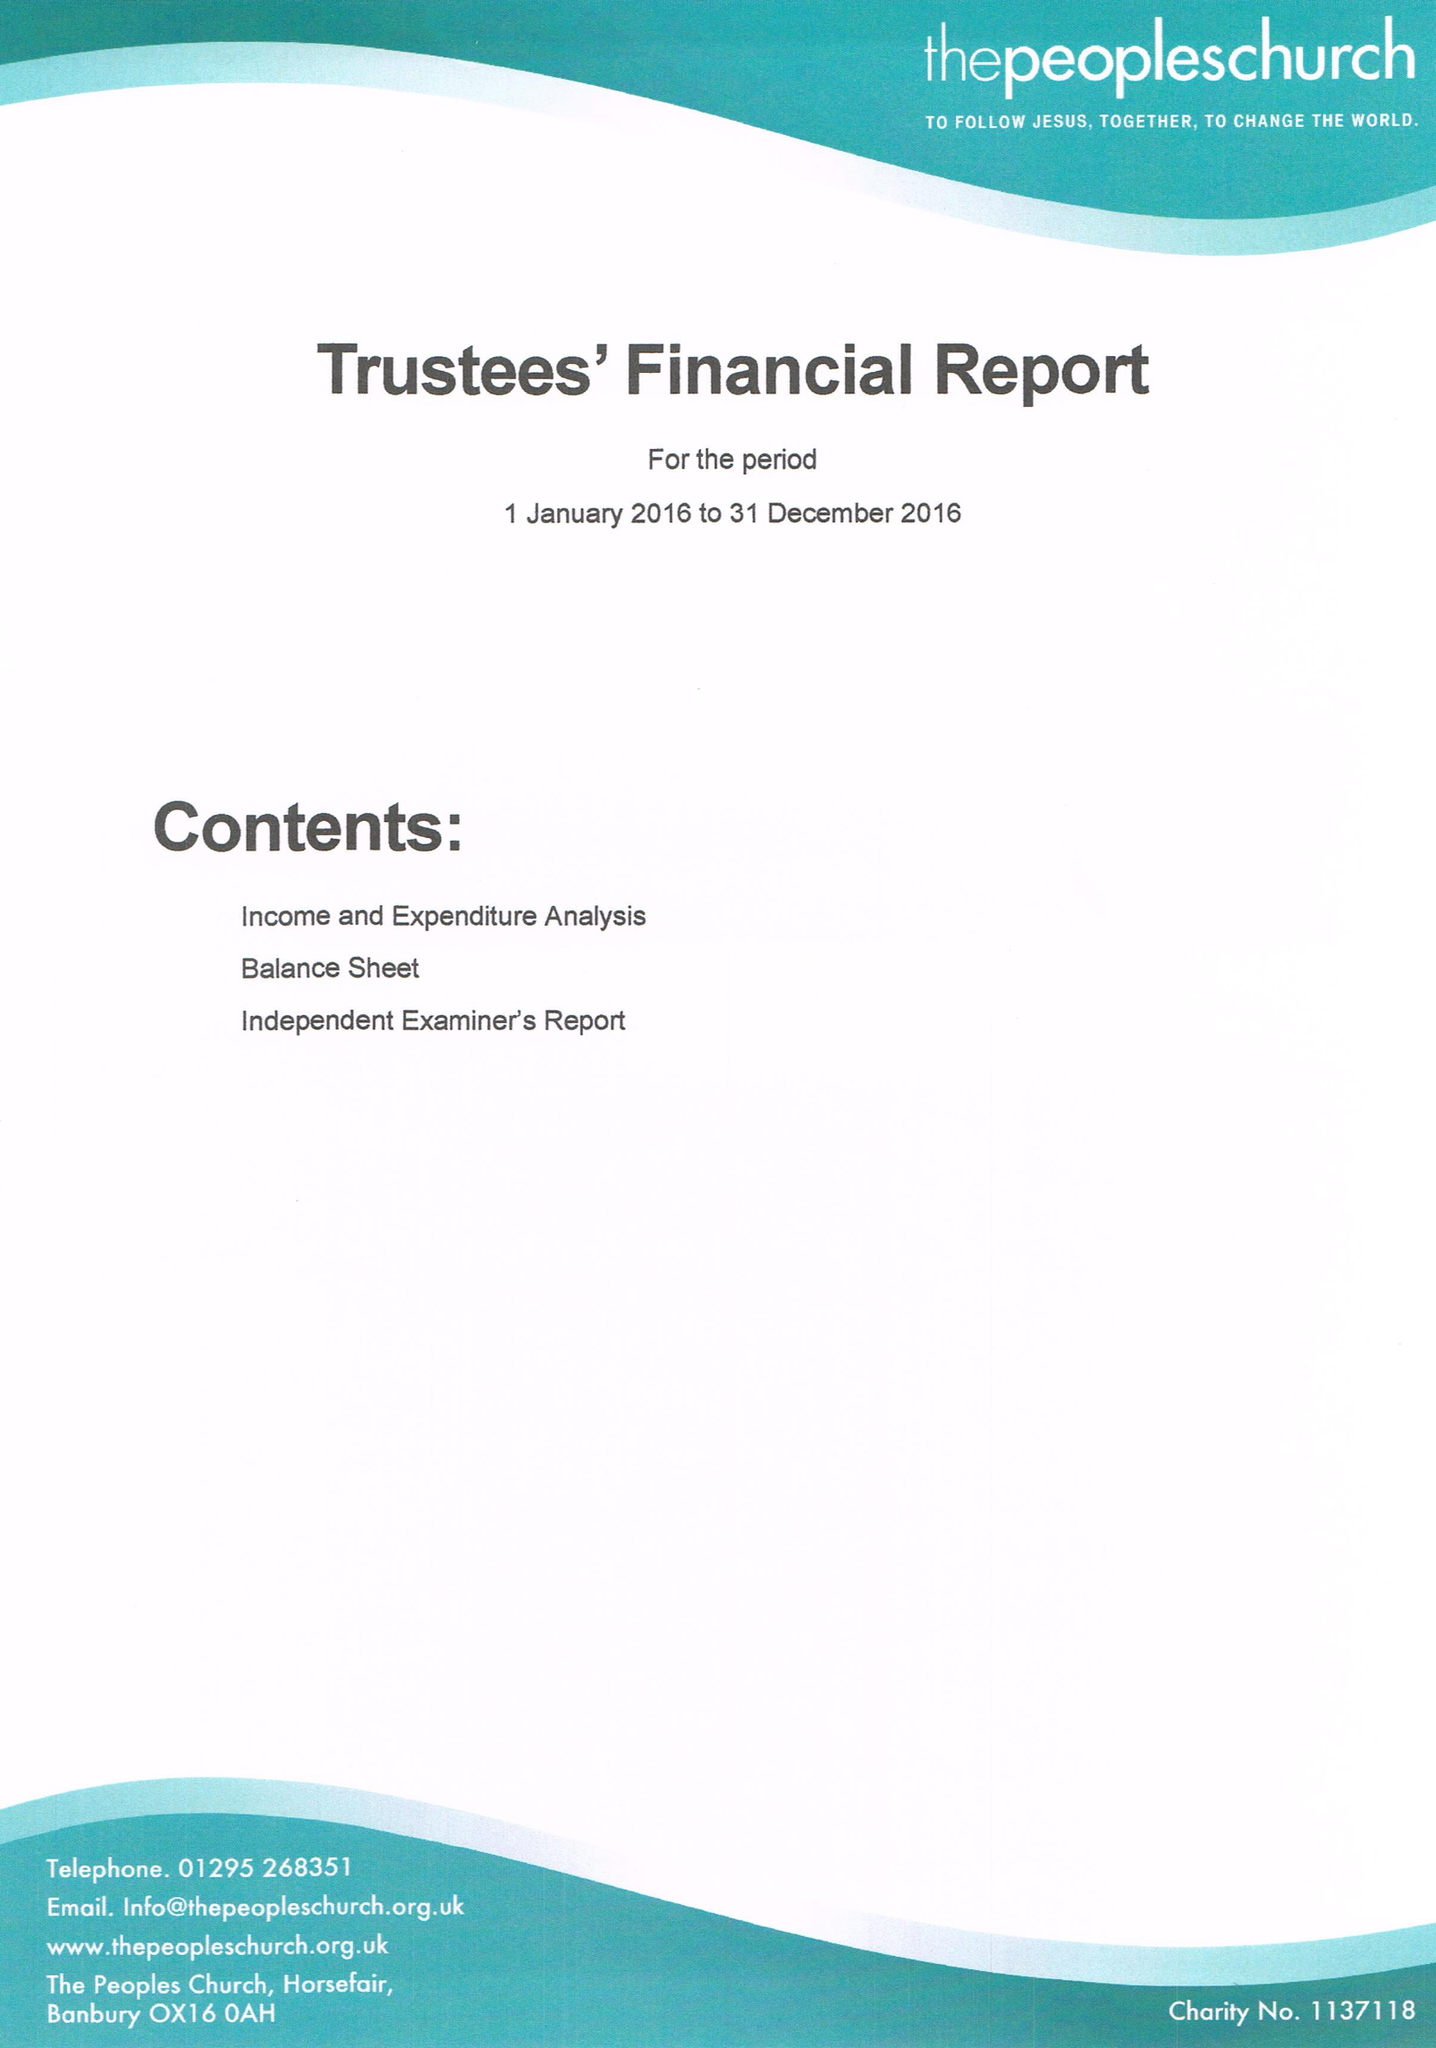What is the value for the address__postcode?
Answer the question using a single word or phrase. OX16 0AH 